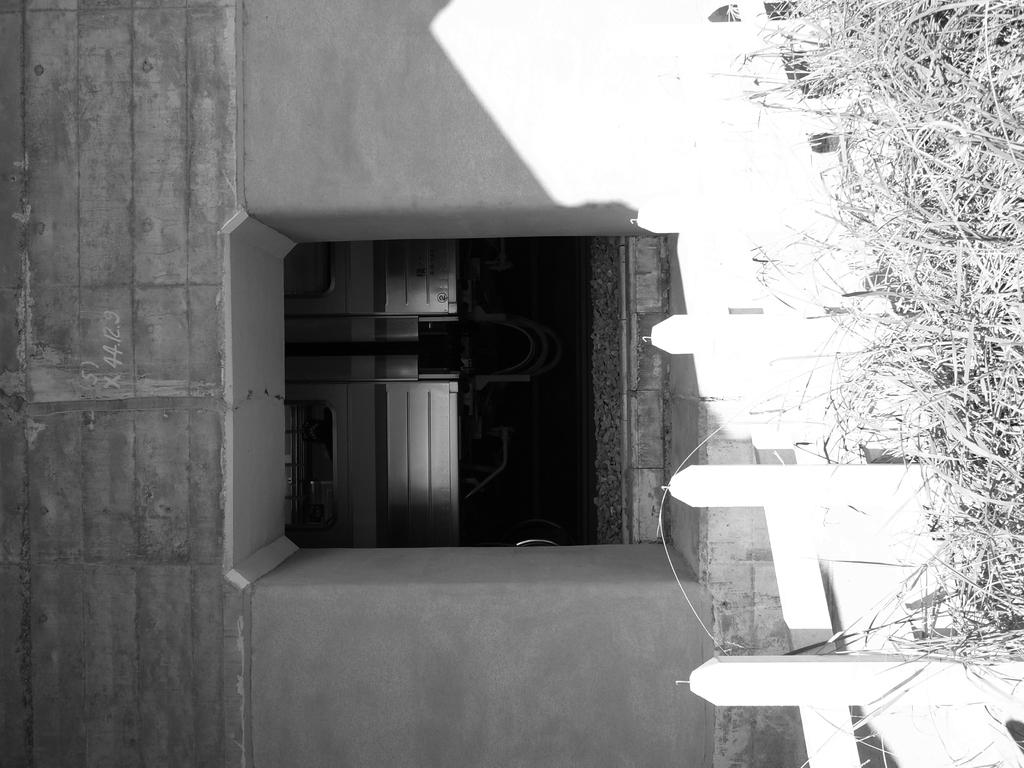What is located in the foreground of the image? There is a boundary in the foreground of the image. What can be seen in the background of the image? There is a building structure in the background of the image. What time of day is it in the image, and how many oranges are on the tree? The time of day and the presence of oranges are not mentioned in the provided facts, so we cannot determine the time of day or the number of oranges in the image. 